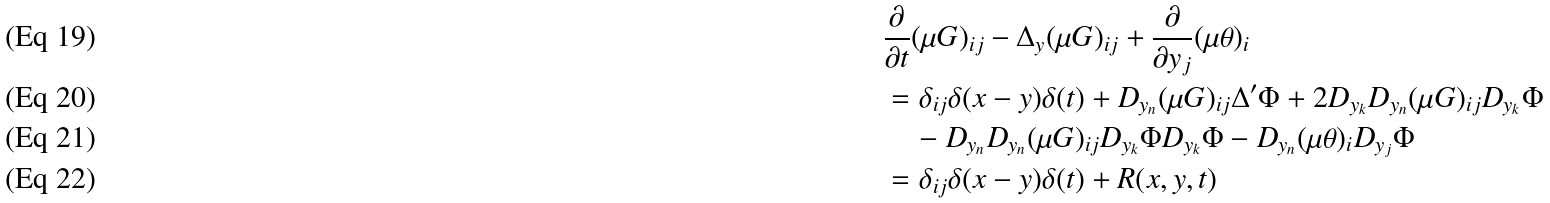<formula> <loc_0><loc_0><loc_500><loc_500>& \frac { \partial } { \partial t } ( \mu G ) _ { i j } - \Delta _ { y } ( \mu G ) _ { i j } + \frac { \partial } { \partial y _ { j } } ( \mu \theta ) _ { i } \\ & = \delta _ { i j } \delta ( x - y ) \delta ( t ) + D _ { y _ { n } } ( \mu G ) _ { i j } \Delta ^ { \prime } \Phi + 2 D _ { y _ { k } } D _ { y _ { n } } ( \mu G ) _ { i j } D _ { y _ { k } } \Phi \\ & \quad - D _ { y _ { n } } D _ { y _ { n } } ( \mu G ) _ { i j } D _ { y _ { k } } \Phi D _ { y _ { k } } \Phi - D _ { y _ { n } } ( \mu \theta ) _ { i } D _ { y _ { j } } \Phi \\ & = \delta _ { i j } \delta ( x - y ) \delta ( t ) + R ( x , y , t )</formula> 